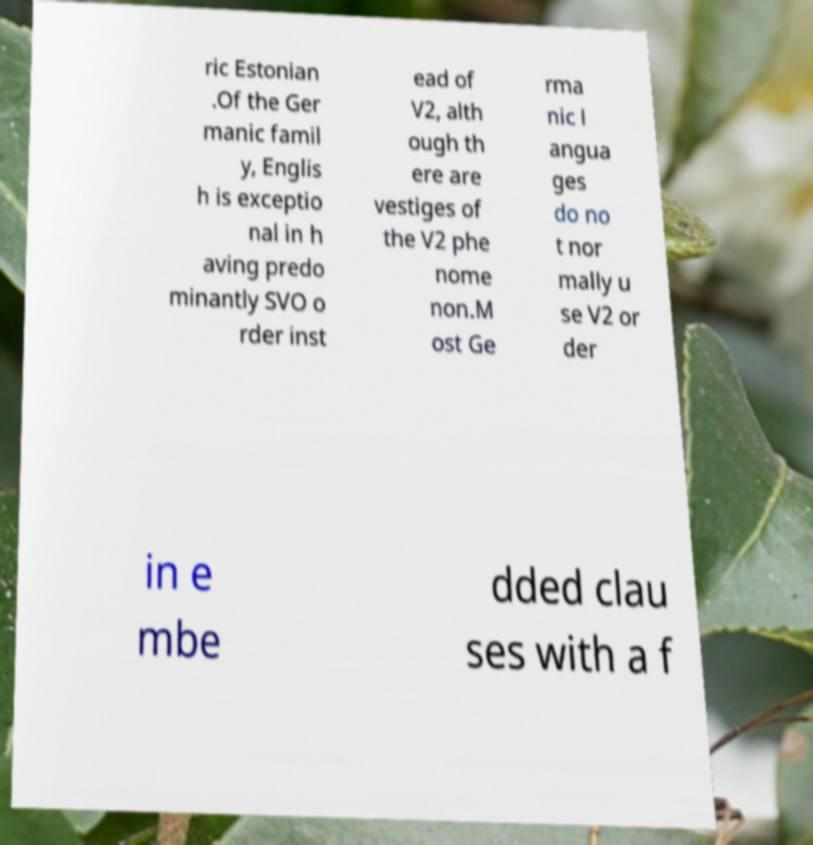Please read and relay the text visible in this image. What does it say? ric Estonian .Of the Ger manic famil y, Englis h is exceptio nal in h aving predo minantly SVO o rder inst ead of V2, alth ough th ere are vestiges of the V2 phe nome non.M ost Ge rma nic l angua ges do no t nor mally u se V2 or der in e mbe dded clau ses with a f 